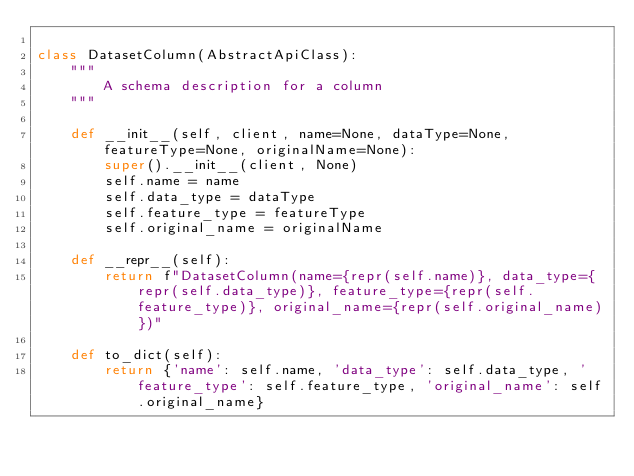<code> <loc_0><loc_0><loc_500><loc_500><_Python_>
class DatasetColumn(AbstractApiClass):
    """
        A schema description for a column
    """

    def __init__(self, client, name=None, dataType=None, featureType=None, originalName=None):
        super().__init__(client, None)
        self.name = name
        self.data_type = dataType
        self.feature_type = featureType
        self.original_name = originalName

    def __repr__(self):
        return f"DatasetColumn(name={repr(self.name)}, data_type={repr(self.data_type)}, feature_type={repr(self.feature_type)}, original_name={repr(self.original_name)})"

    def to_dict(self):
        return {'name': self.name, 'data_type': self.data_type, 'feature_type': self.feature_type, 'original_name': self.original_name}
</code> 